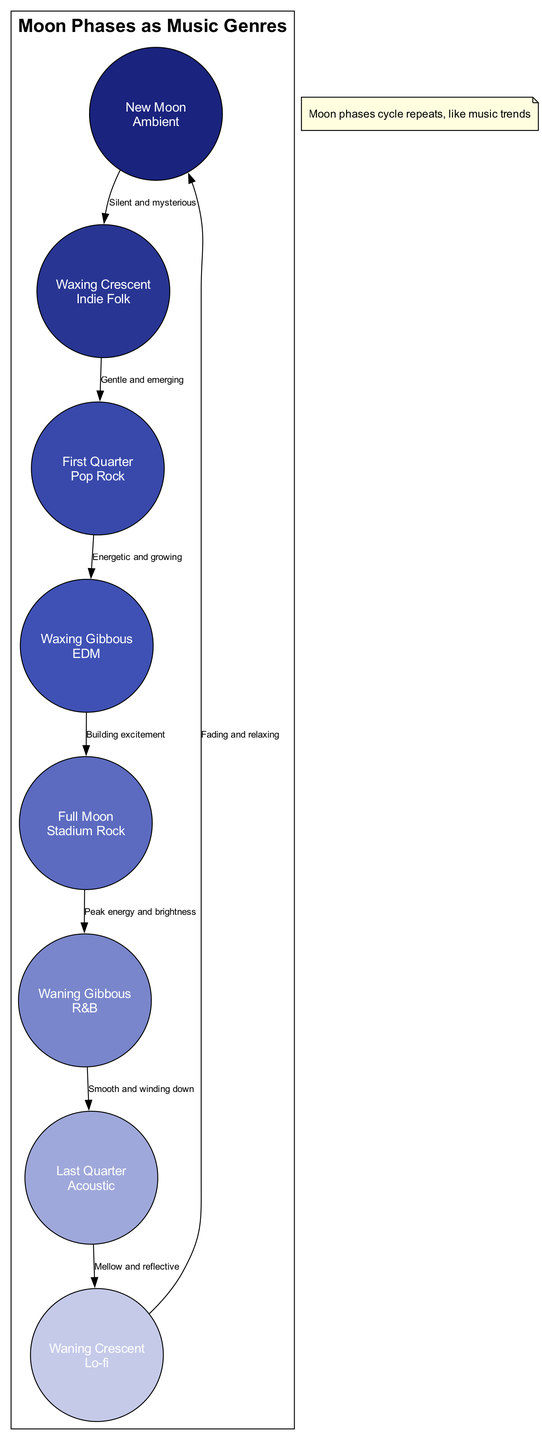What genre is associated with the New Moon? According to the diagram, the New Moon phase is connected with the genre Ambient.
Answer: Ambient How many phases of the moon are represented in the diagram? The diagram lists a total of eight phases of the moon, which are clearly labeled.
Answer: Eight What description is given for the Full Moon? The Full Moon phase is described as "Peak energy and brightness," showing its significance in the cycle.
Answer: Peak energy and brightness Which genre corresponds with the waxing phases? The waxing phases include Waxing Crescent as Indie Folk and Waxing Gibbous as EDM, both of which signify growth and energy.
Answer: Indie Folk, EDM What is the relationship between the Waxing Gibbous and Waning Gibbous phases? The diagram shows a direct connection through an edge, indicating that the Waxing Gibbous leads into the Full Moon, followed by the Waning Gibbous.
Answer: Sequential connection What is the genre of the Last Quarter phase? The Last Quarter phase is associated with the genre Acoustic, which is included in the circular arrangement of phases.
Answer: Acoustic Which phase has the "Silent and mysterious" description? The New Moon phase is specifically described as "Silent and mysterious," highlighting its unique nature.
Answer: Silent and mysterious What is the genre associated with the phase right before the Full Moon? The phase right before the Full Moon is the Waxing Gibbous, which corresponds to the EDM genre according to the diagram.
Answer: EDM What note is included at the bottom of the diagram? The diagram includes a note stating, "Moon phases cycle repeats, like music trends," which emphasizes the cyclical nature of both phenomena.
Answer: Moon phases cycle repeats, like music trends 